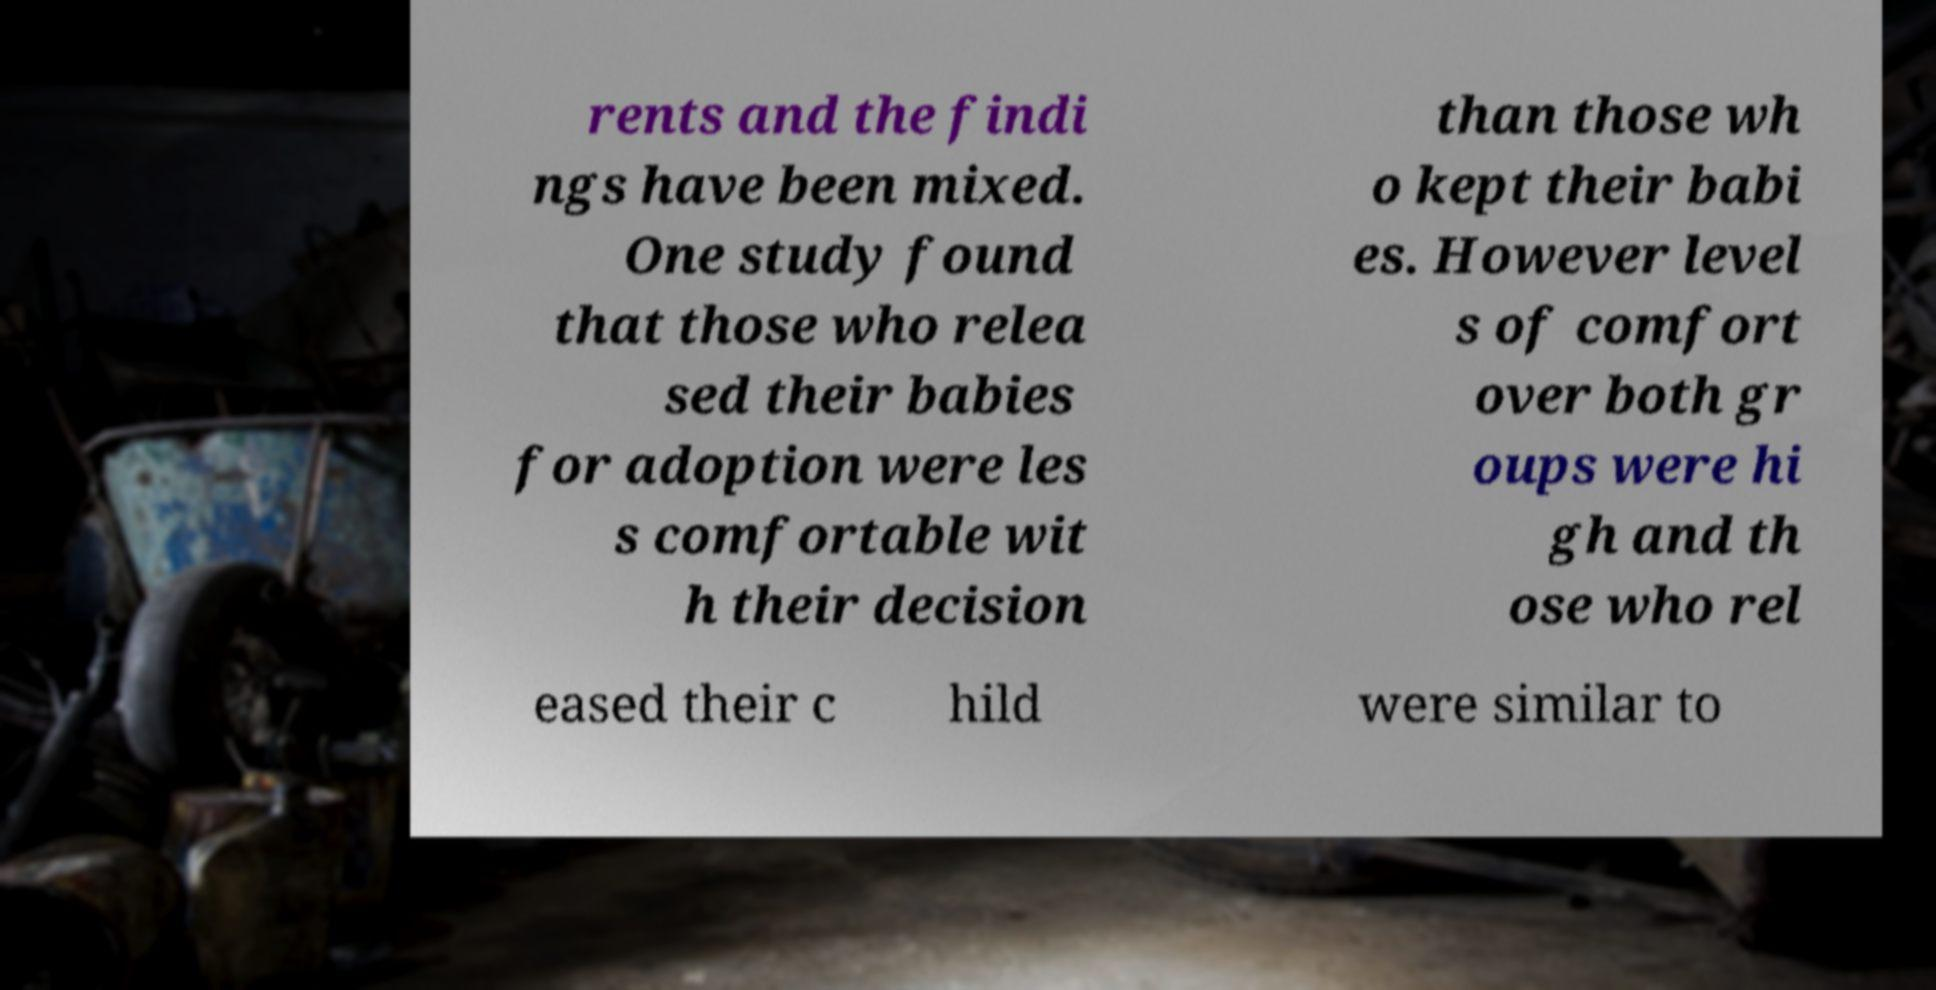There's text embedded in this image that I need extracted. Can you transcribe it verbatim? rents and the findi ngs have been mixed. One study found that those who relea sed their babies for adoption were les s comfortable wit h their decision than those wh o kept their babi es. However level s of comfort over both gr oups were hi gh and th ose who rel eased their c hild were similar to 